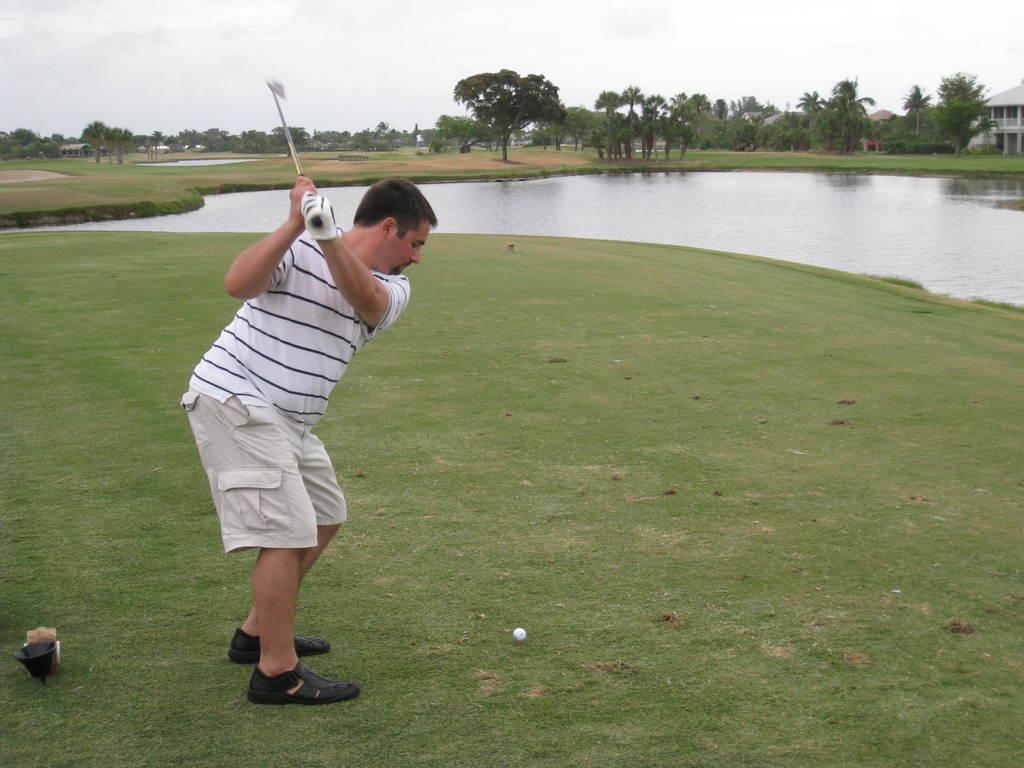How would you summarize this image in a sentence or two? In this picture there is a person standing and holding the bat and there is a white ball on the grass. At the back there are buildings and trees. At the top there is sky. At the bottom there is grass and water. 